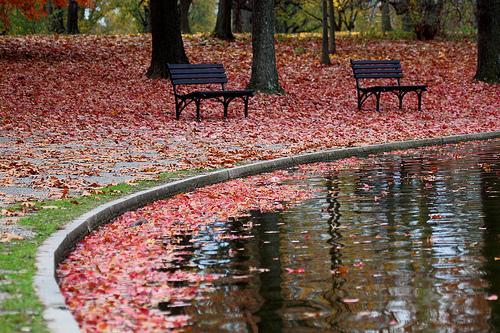Mention the major elements in the picture and how they relate to each other. The image showcases a park in autumn with red leaves on trees and ground, green grass near a calm pond, two black benches by the trees, and reflections of park elements in the water. Summarize the image in one sentence. A serene autumn park scene featuring trees with vivid red leaves, black benches, and tranquil pond reflecting its surroundings. Describe the image focusing on the elements related to water. The image includes a calm pond with red leaves floating on the surface, reflections of park benches and trees in the water, and a concrete border around the water. Explain what the overall theme of the image is. The image represents a peaceful autumn park scene featuring benches, trees with colorful leaves, and a serene pond. What is the overall mood conveyed by the image? The image conveys a sense of peace and tranquility in an autumn park setting with benches, trees, and a calm pond. List the top three most striking features in the image. 3. Reflections of park elements in the calm water. Briefly describe the scene and setting of the image. An autumn scene in a park with red leaves, benches, trees, and a pond reflecting the surroundings. Describe the scenery in the image and the atmosphere it conveys. A picturesque park scenery in autumn with vibrant red leaves, calm pond, black benches, and trees in the background, emanating tranquility. What does the image tell you about the season and location? The image depicts an autumn scene at a park with fall foliage and a quiet pond surrounded by benches and trees. Mention the most predominant color in the image and its significance. The most predominant color is red, conveying the beautiful autumn foliage in the park. 